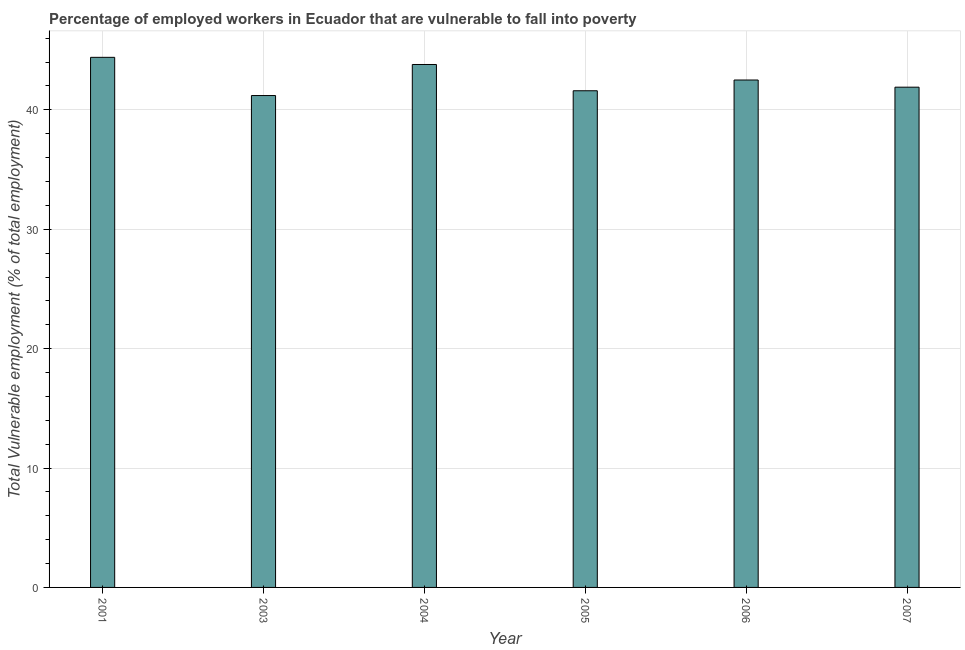What is the title of the graph?
Provide a succinct answer. Percentage of employed workers in Ecuador that are vulnerable to fall into poverty. What is the label or title of the Y-axis?
Provide a short and direct response. Total Vulnerable employment (% of total employment). What is the total vulnerable employment in 2007?
Provide a succinct answer. 41.9. Across all years, what is the maximum total vulnerable employment?
Your answer should be compact. 44.4. Across all years, what is the minimum total vulnerable employment?
Make the answer very short. 41.2. What is the sum of the total vulnerable employment?
Your answer should be very brief. 255.4. What is the average total vulnerable employment per year?
Make the answer very short. 42.57. What is the median total vulnerable employment?
Make the answer very short. 42.2. In how many years, is the total vulnerable employment greater than 36 %?
Your answer should be compact. 6. Do a majority of the years between 2001 and 2004 (inclusive) have total vulnerable employment greater than 40 %?
Give a very brief answer. Yes. What is the ratio of the total vulnerable employment in 2004 to that in 2005?
Make the answer very short. 1.05. Is the difference between the total vulnerable employment in 2003 and 2004 greater than the difference between any two years?
Keep it short and to the point. No. What is the difference between the highest and the second highest total vulnerable employment?
Offer a terse response. 0.6. Is the sum of the total vulnerable employment in 2001 and 2005 greater than the maximum total vulnerable employment across all years?
Your answer should be very brief. Yes. What is the difference between the highest and the lowest total vulnerable employment?
Your response must be concise. 3.2. How many bars are there?
Provide a succinct answer. 6. How many years are there in the graph?
Your answer should be compact. 6. What is the difference between two consecutive major ticks on the Y-axis?
Keep it short and to the point. 10. Are the values on the major ticks of Y-axis written in scientific E-notation?
Provide a short and direct response. No. What is the Total Vulnerable employment (% of total employment) of 2001?
Your response must be concise. 44.4. What is the Total Vulnerable employment (% of total employment) of 2003?
Keep it short and to the point. 41.2. What is the Total Vulnerable employment (% of total employment) in 2004?
Make the answer very short. 43.8. What is the Total Vulnerable employment (% of total employment) of 2005?
Ensure brevity in your answer.  41.6. What is the Total Vulnerable employment (% of total employment) of 2006?
Your response must be concise. 42.5. What is the Total Vulnerable employment (% of total employment) of 2007?
Keep it short and to the point. 41.9. What is the difference between the Total Vulnerable employment (% of total employment) in 2001 and 2004?
Provide a short and direct response. 0.6. What is the difference between the Total Vulnerable employment (% of total employment) in 2001 and 2005?
Ensure brevity in your answer.  2.8. What is the difference between the Total Vulnerable employment (% of total employment) in 2001 and 2006?
Your answer should be compact. 1.9. What is the difference between the Total Vulnerable employment (% of total employment) in 2003 and 2007?
Offer a very short reply. -0.7. What is the difference between the Total Vulnerable employment (% of total employment) in 2004 and 2005?
Provide a short and direct response. 2.2. What is the difference between the Total Vulnerable employment (% of total employment) in 2004 and 2007?
Offer a very short reply. 1.9. What is the difference between the Total Vulnerable employment (% of total employment) in 2005 and 2007?
Your response must be concise. -0.3. What is the difference between the Total Vulnerable employment (% of total employment) in 2006 and 2007?
Offer a very short reply. 0.6. What is the ratio of the Total Vulnerable employment (% of total employment) in 2001 to that in 2003?
Your answer should be very brief. 1.08. What is the ratio of the Total Vulnerable employment (% of total employment) in 2001 to that in 2005?
Offer a very short reply. 1.07. What is the ratio of the Total Vulnerable employment (% of total employment) in 2001 to that in 2006?
Your answer should be compact. 1.04. What is the ratio of the Total Vulnerable employment (% of total employment) in 2001 to that in 2007?
Ensure brevity in your answer.  1.06. What is the ratio of the Total Vulnerable employment (% of total employment) in 2003 to that in 2004?
Make the answer very short. 0.94. What is the ratio of the Total Vulnerable employment (% of total employment) in 2003 to that in 2005?
Keep it short and to the point. 0.99. What is the ratio of the Total Vulnerable employment (% of total employment) in 2003 to that in 2006?
Keep it short and to the point. 0.97. What is the ratio of the Total Vulnerable employment (% of total employment) in 2004 to that in 2005?
Ensure brevity in your answer.  1.05. What is the ratio of the Total Vulnerable employment (% of total employment) in 2004 to that in 2006?
Provide a succinct answer. 1.03. What is the ratio of the Total Vulnerable employment (% of total employment) in 2004 to that in 2007?
Your response must be concise. 1.04. What is the ratio of the Total Vulnerable employment (% of total employment) in 2005 to that in 2006?
Offer a terse response. 0.98. What is the ratio of the Total Vulnerable employment (% of total employment) in 2005 to that in 2007?
Make the answer very short. 0.99. What is the ratio of the Total Vulnerable employment (% of total employment) in 2006 to that in 2007?
Provide a short and direct response. 1.01. 